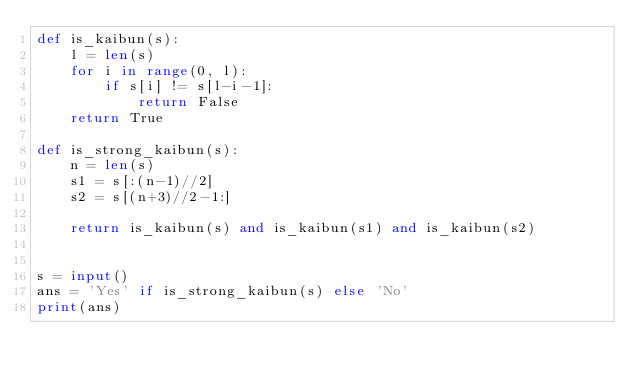<code> <loc_0><loc_0><loc_500><loc_500><_Python_>def is_kaibun(s):
    l = len(s)
    for i in range(0, l):
        if s[i] != s[l-i-1]:
            return False
    return True

def is_strong_kaibun(s):
    n = len(s)
    s1 = s[:(n-1)//2]
    s2 = s[(n+3)//2-1:]

    return is_kaibun(s) and is_kaibun(s1) and is_kaibun(s2)


s = input()
ans = 'Yes' if is_strong_kaibun(s) else 'No'
print(ans)
</code> 